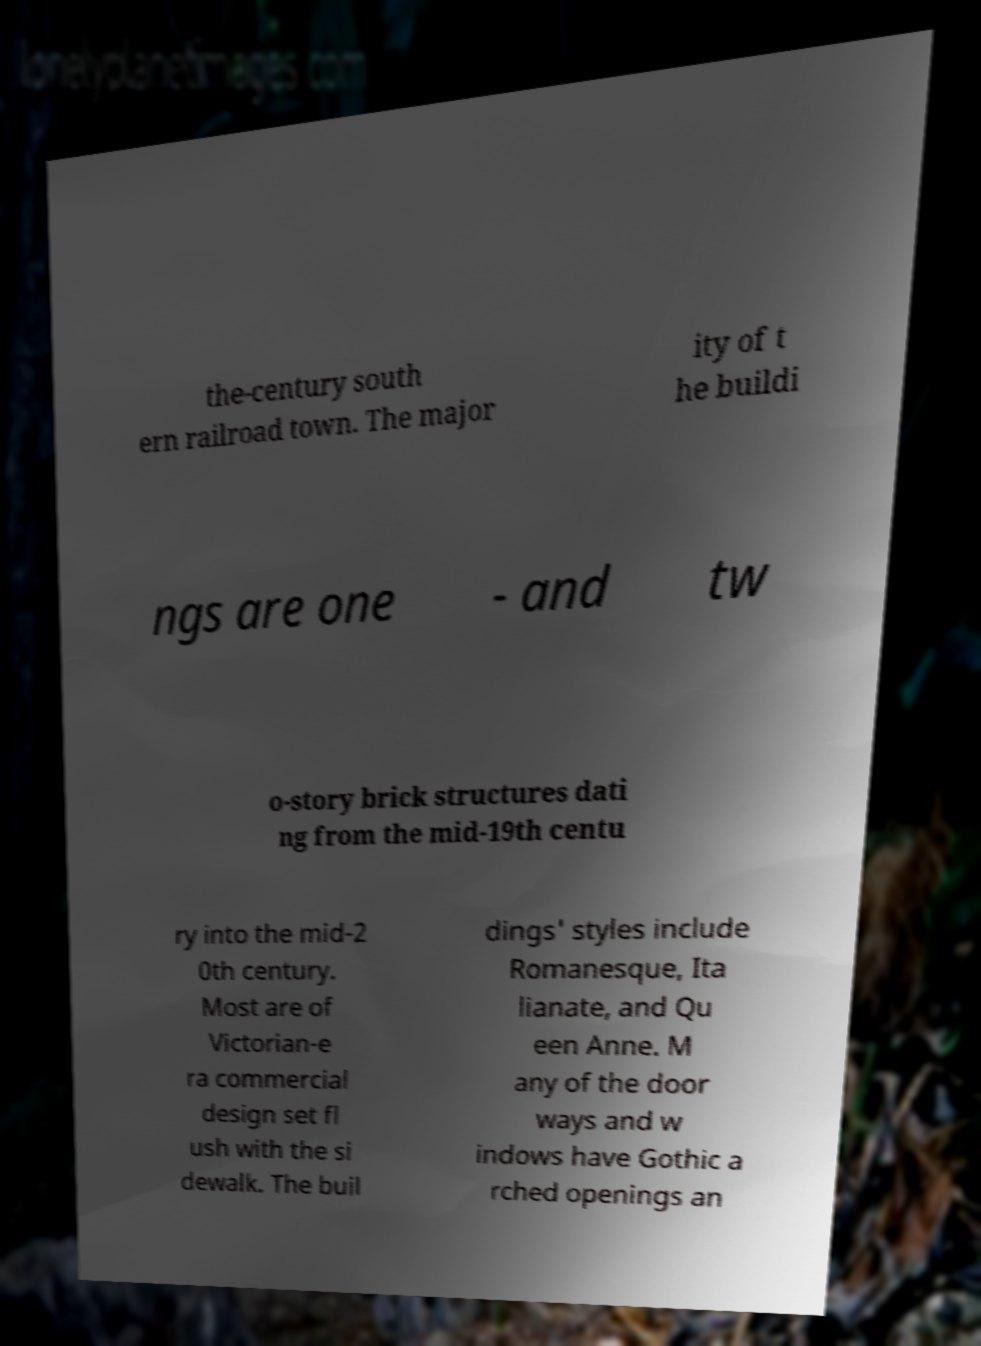For documentation purposes, I need the text within this image transcribed. Could you provide that? the-century south ern railroad town. The major ity of t he buildi ngs are one - and tw o-story brick structures dati ng from the mid-19th centu ry into the mid-2 0th century. Most are of Victorian-e ra commercial design set fl ush with the si dewalk. The buil dings' styles include Romanesque, Ita lianate, and Qu een Anne. M any of the door ways and w indows have Gothic a rched openings an 